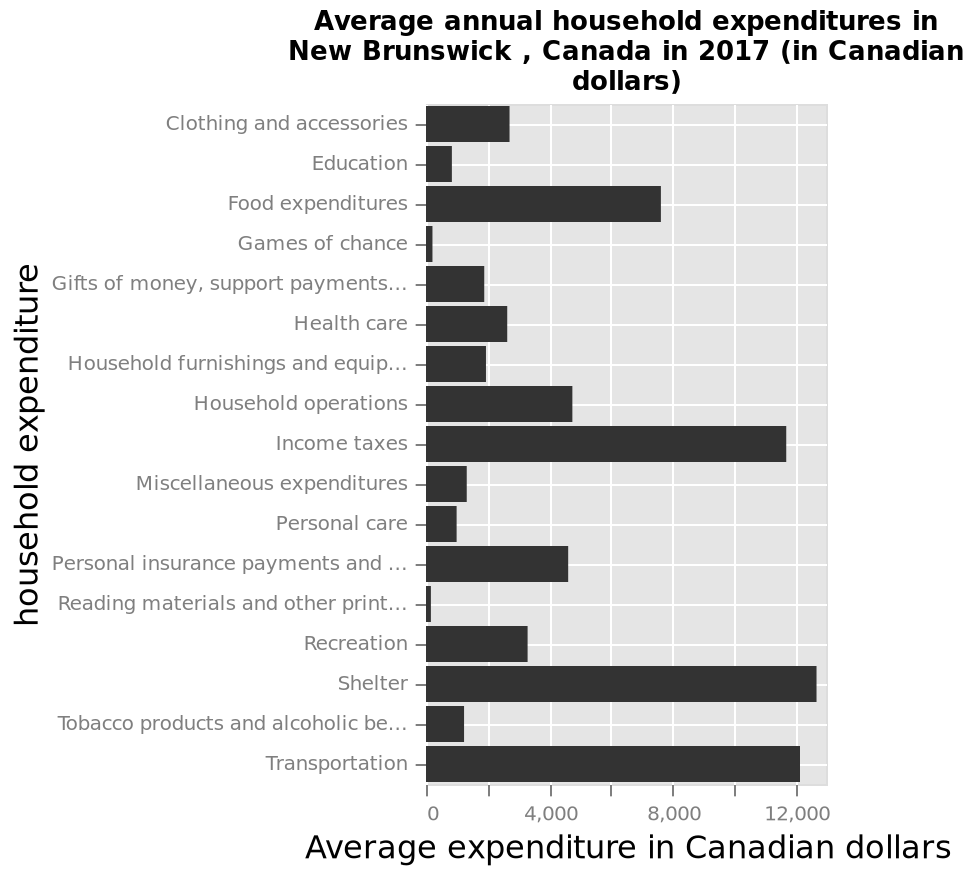<image>
What are the categories represented on the y-axis?  The categories represented on the y-axis range from Clothing and accessories to Transportation. 